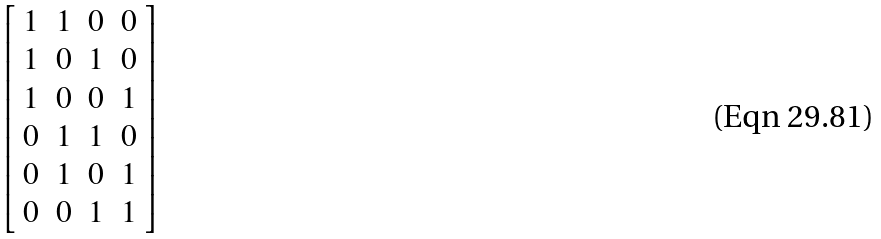Convert formula to latex. <formula><loc_0><loc_0><loc_500><loc_500>\left [ \begin{array} { c c c c } 1 & 1 & 0 & 0 \\ 1 & 0 & 1 & 0 \\ 1 & 0 & 0 & 1 \\ 0 & 1 & 1 & 0 \\ 0 & 1 & 0 & 1 \\ 0 & 0 & 1 & 1 \end{array} \right ]</formula> 